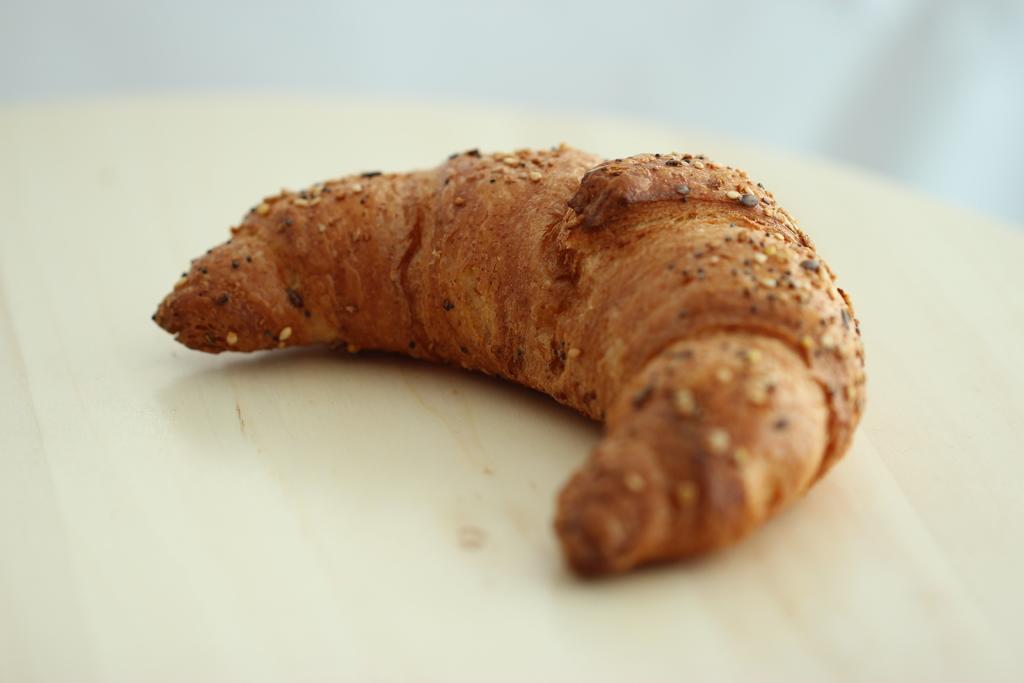How would you summarize this image in a sentence or two? This is a zoomed in picture. In the center there is a food item on the top of an object. the background of the image is blur. 